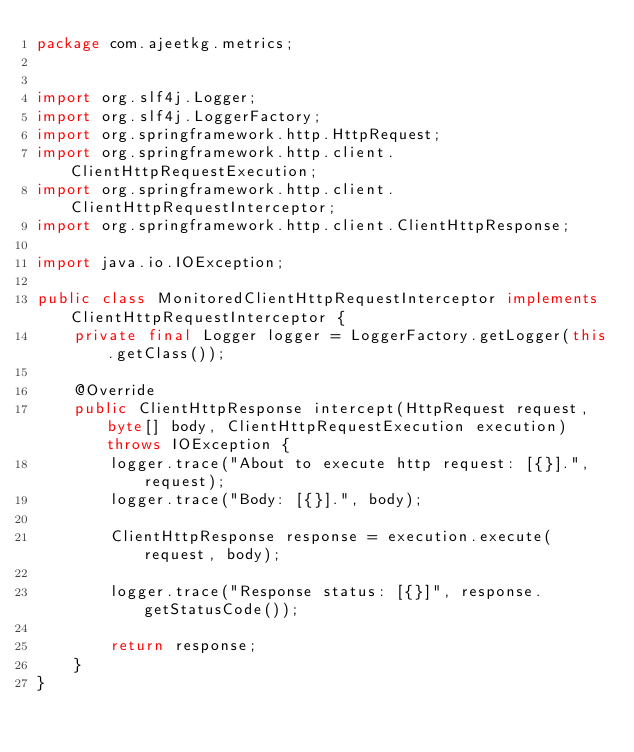<code> <loc_0><loc_0><loc_500><loc_500><_Java_>package com.ajeetkg.metrics;


import org.slf4j.Logger;
import org.slf4j.LoggerFactory;
import org.springframework.http.HttpRequest;
import org.springframework.http.client.ClientHttpRequestExecution;
import org.springframework.http.client.ClientHttpRequestInterceptor;
import org.springframework.http.client.ClientHttpResponse;

import java.io.IOException;

public class MonitoredClientHttpRequestInterceptor implements ClientHttpRequestInterceptor {
    private final Logger logger = LoggerFactory.getLogger(this.getClass());

    @Override
    public ClientHttpResponse intercept(HttpRequest request, byte[] body, ClientHttpRequestExecution execution) throws IOException {
        logger.trace("About to execute http request: [{}].", request);
        logger.trace("Body: [{}].", body);

        ClientHttpResponse response = execution.execute(request, body);

        logger.trace("Response status: [{}]", response.getStatusCode());

        return response;
    }
}
</code> 